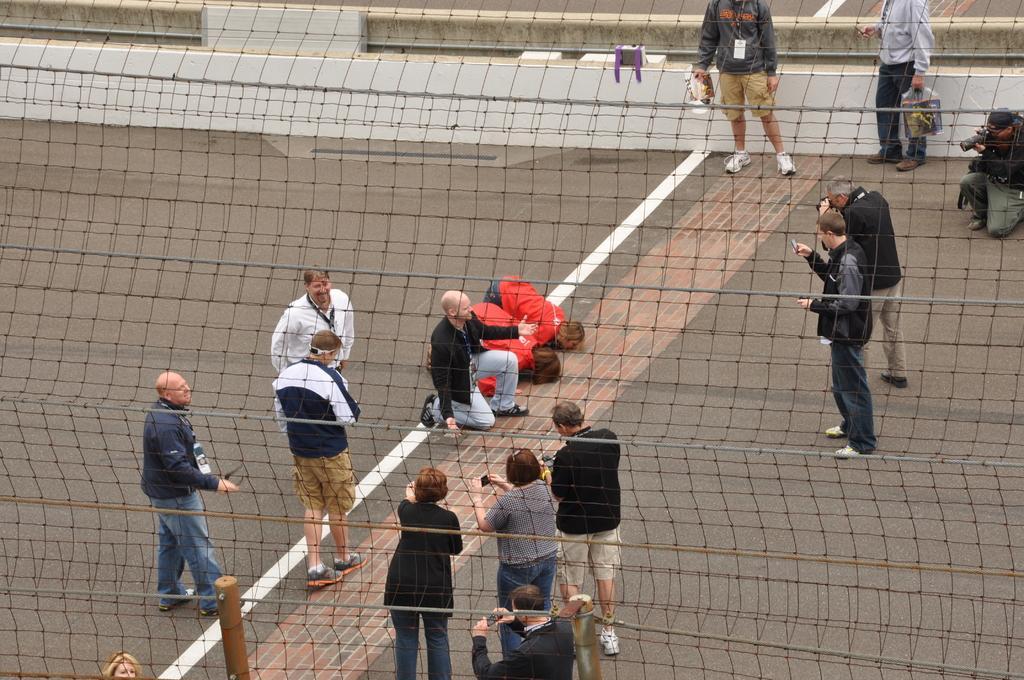How would you summarize this image in a sentence or two? In the foreground of the picture I can see the net fence. I can see a few persons standing on the floor. I can see a few people holding the camera and they are capturing images. 